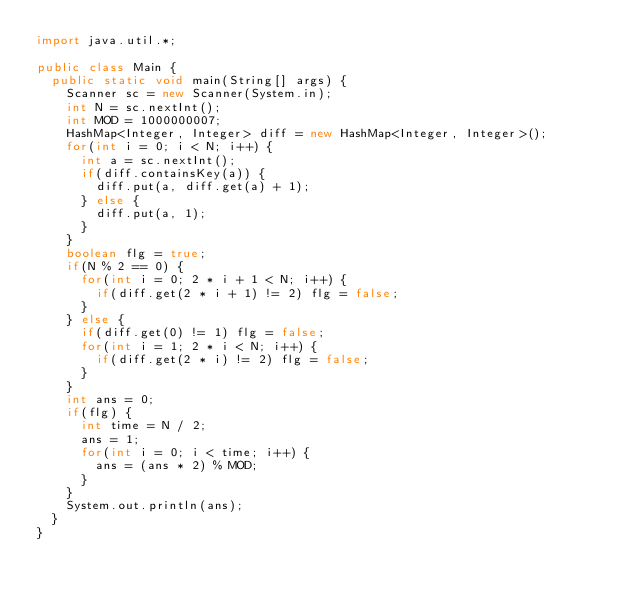Convert code to text. <code><loc_0><loc_0><loc_500><loc_500><_Java_>import java.util.*;

public class Main {
  public static void main(String[] args) {
    Scanner sc = new Scanner(System.in);
    int N = sc.nextInt();
    int MOD = 1000000007;
    HashMap<Integer, Integer> diff = new HashMap<Integer, Integer>();
    for(int i = 0; i < N; i++) {
      int a = sc.nextInt();
      if(diff.containsKey(a)) {
        diff.put(a, diff.get(a) + 1);
      } else {
        diff.put(a, 1);
      }
    }
    boolean flg = true;
    if(N % 2 == 0) {
      for(int i = 0; 2 * i + 1 < N; i++) {
        if(diff.get(2 * i + 1) != 2) flg = false;
      }
    } else {
      if(diff.get(0) != 1) flg = false;
      for(int i = 1; 2 * i < N; i++) {
        if(diff.get(2 * i) != 2) flg = false;
      }
    }
    int ans = 0;
    if(flg) {
      int time = N / 2;
      ans = 1;
      for(int i = 0; i < time; i++) {
        ans = (ans * 2) % MOD;
      }
    }
    System.out.println(ans);
  }
}</code> 